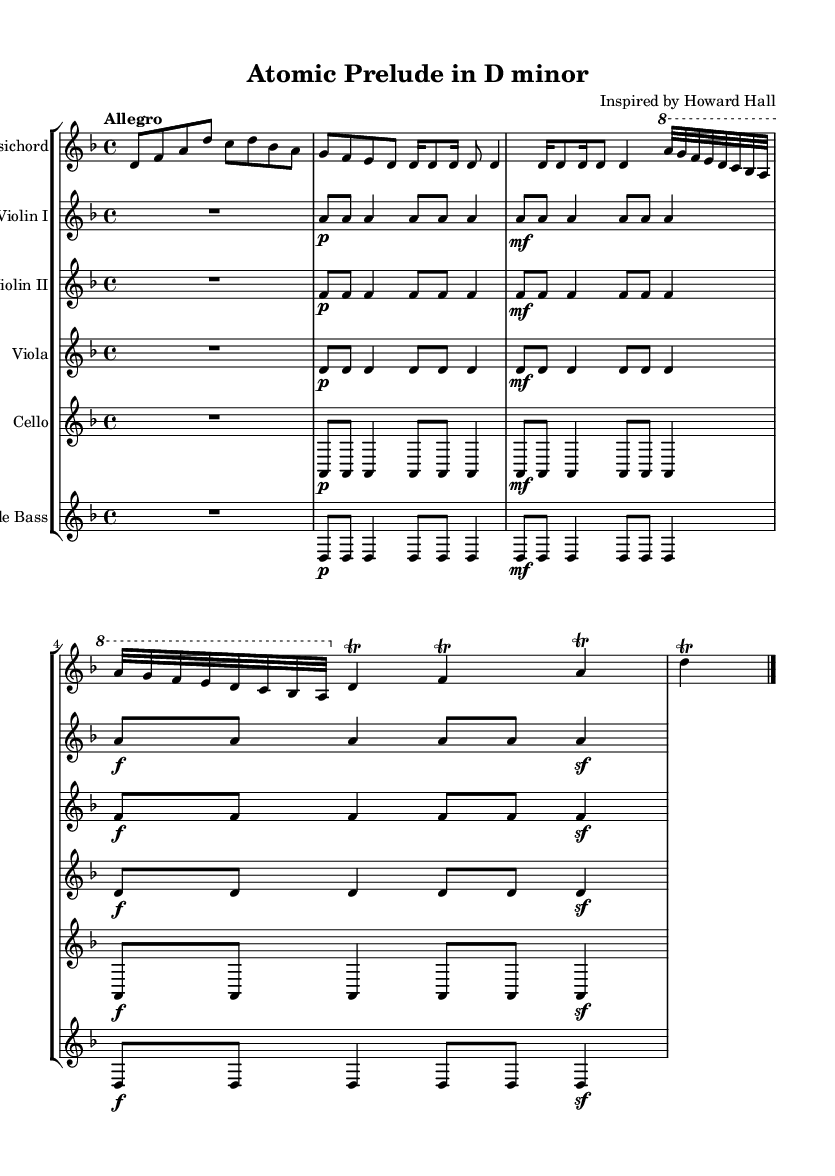What is the key signature of this music? The key signature is D minor, as indicated by one flat (B flat) in the beginning of the score.
Answer: D minor What is the time signature of this music? The time signature is 4/4, shown at the beginning, indicating four beats per measure.
Answer: 4/4 What is the tempo marking of this piece? The tempo marking is "Allegro," which suggests a fast and lively pace typical for Baroque music.
Answer: Allegro How many instruments are featured in this score? There are five instruments featured: Harpsichord, Violin I, Violin II, Viola, and Cello, as seen in the staff group names.
Answer: Five What is the main theme of the piece as inferred from its title? The main theme is atomic structure and energy, which is suggested by the title "Atomic Prelude in D minor."
Answer: Atomic structure and energy How many times is the note 'a' repeated in the Violin I part? The note 'a' is repeated a total of 10 times in the Violin I part, when counting each instance.
Answer: Ten What type of ornamentation is used in the Harpsichord part? The ornamentation used is trills, which are indicated by the symbol "trill" over specific notes in the Harpsichord part.
Answer: Trills 